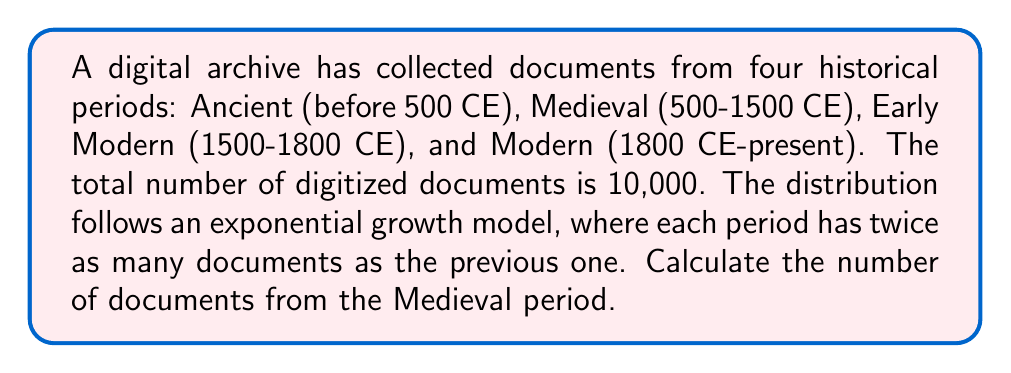Can you answer this question? Let's approach this step-by-step:

1) Let $x$ be the number of documents from the Ancient period.

2) Given the exponential growth model, we can express the number of documents for each period:
   Ancient: $x$
   Medieval: $2x$
   Early Modern: $4x$
   Modern: $8x$

3) The total number of documents is 10,000, so we can set up the equation:

   $$x + 2x + 4x + 8x = 10000$$

4) Simplify the left side of the equation:

   $$15x = 10000$$

5) Solve for $x$:

   $$x = \frac{10000}{15} \approx 666.67$$

6) The question asks for the number of documents from the Medieval period, which is $2x$:

   $$2x = 2 * \frac{10000}{15} \approx 1333.33$$

7) Since we're dealing with whole documents, we round to the nearest integer:

   $$2x \approx 1333$$
Answer: The Medieval period contains approximately 1,333 digitized documents. 